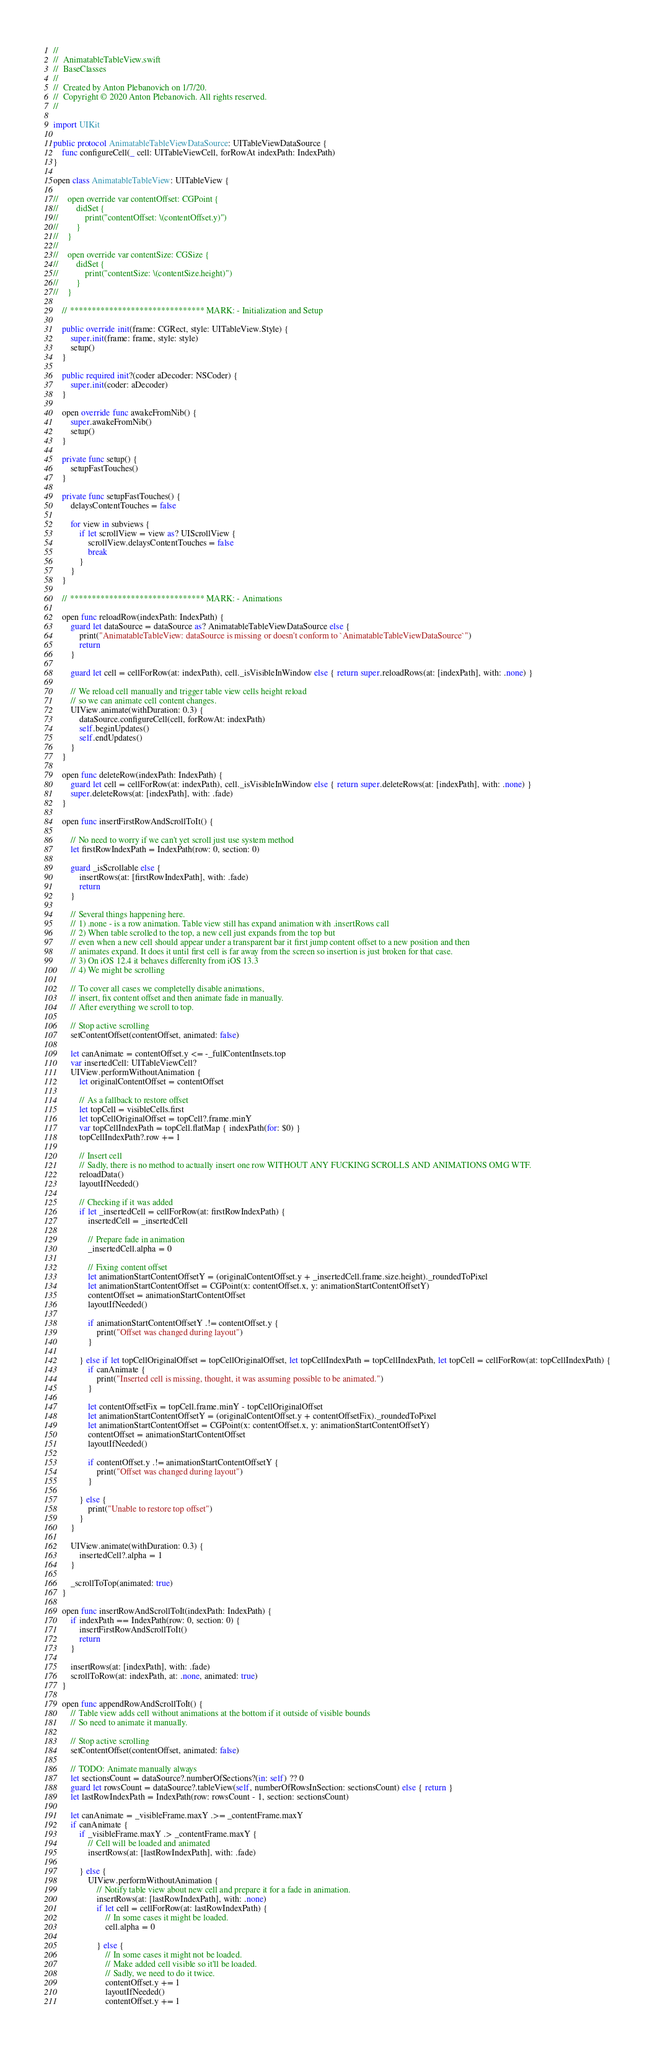<code> <loc_0><loc_0><loc_500><loc_500><_Swift_>//
//  AnimatableTableView.swift
//  BaseClasses
//
//  Created by Anton Plebanovich on 1/7/20.
//  Copyright © 2020 Anton Plebanovich. All rights reserved.
//

import UIKit

public protocol AnimatableTableViewDataSource: UITableViewDataSource {
    func configureCell(_ cell: UITableViewCell, forRowAt indexPath: IndexPath)
}

open class AnimatableTableView: UITableView {
    
//    open override var contentOffset: CGPoint {
//        didSet {
//            print("contentOffset: \(contentOffset.y)")
//        }
//    }
//    
//    open override var contentSize: CGSize {
//        didSet {
//            print("contentSize: \(contentSize.height)")
//        }
//    }
    
    // ******************************* MARK: - Initialization and Setup
    
    public override init(frame: CGRect, style: UITableView.Style) {
        super.init(frame: frame, style: style)
        setup()
    }
    
    public required init?(coder aDecoder: NSCoder) {
        super.init(coder: aDecoder)
    }
    
    open override func awakeFromNib() {
        super.awakeFromNib()
        setup()
    }
    
    private func setup() {
        setupFastTouches()
    }
    
    private func setupFastTouches() {
        delaysContentTouches = false
        
        for view in subviews {
            if let scrollView = view as? UIScrollView {
                scrollView.delaysContentTouches = false
                break
            }
        }
    }
    
    // ******************************* MARK: - Animations
    
    open func reloadRow(indexPath: IndexPath) {
        guard let dataSource = dataSource as? AnimatableTableViewDataSource else {
            print("AnimatableTableView: dataSource is missing or doesn't conform to `AnimatableTableViewDataSource`")
            return
        }
        
        guard let cell = cellForRow(at: indexPath), cell._isVisibleInWindow else { return super.reloadRows(at: [indexPath], with: .none) }
        
        // We reload cell manually and trigger table view cells height reload
        // so we can animate cell content changes.
        UIView.animate(withDuration: 0.3) {
            dataSource.configureCell(cell, forRowAt: indexPath)
            self.beginUpdates()
            self.endUpdates()
        }
    }
    
    open func deleteRow(indexPath: IndexPath) {
        guard let cell = cellForRow(at: indexPath), cell._isVisibleInWindow else { return super.deleteRows(at: [indexPath], with: .none) }
        super.deleteRows(at: [indexPath], with: .fade)
    }
    
    open func insertFirstRowAndScrollToIt() {
        
        // No need to worry if we can't yet scroll just use system method
        let firstRowIndexPath = IndexPath(row: 0, section: 0)
        
        guard _isScrollable else {
            insertRows(at: [firstRowIndexPath], with: .fade)
            return
        }
        
        // Several things happening here.
        // 1) .none - is a row animation. Table view still has expand animation with .insertRows call
        // 2) When table scrolled to the top, a new cell just expands from the top but
        // even when a new cell should appear under a transparent bar it first jump content offset to a new position and then
        // animates expand. It does it until first cell is far away from the screen so insertion is just broken for that case.
        // 3) On iOS 12.4 it behaves differenlty from iOS 13.3
        // 4) We might be scrolling
        
        // To cover all cases we completelly disable animations,
        // insert, fix content offset and then animate fade in manually.
        // After everything we scroll to top.
        
        // Stop active scrolling
        setContentOffset(contentOffset, animated: false)
        
        let canAnimate = contentOffset.y <= -_fullContentInsets.top
        var insertedCell: UITableViewCell?
        UIView.performWithoutAnimation {
            let originalContentOffset = contentOffset
            
            // As a fallback to restore offset
            let topCell = visibleCells.first
            let topCellOriginalOffset = topCell?.frame.minY
            var topCellIndexPath = topCell.flatMap { indexPath(for: $0) }
            topCellIndexPath?.row += 1
            
            // Insert cell
            // Sadly, there is no method to actually insert one row WITHOUT ANY FUCKING SCROLLS AND ANIMATIONS OMG WTF.
            reloadData()
            layoutIfNeeded()
            
            // Checking if it was added
            if let _insertedCell = cellForRow(at: firstRowIndexPath) {
                insertedCell = _insertedCell
                
                // Prepare fade in animation
                _insertedCell.alpha = 0
                
                // Fixing content offset
                let animationStartContentOffsetY = (originalContentOffset.y + _insertedCell.frame.size.height)._roundedToPixel
                let animationStartContentOffset = CGPoint(x: contentOffset.x, y: animationStartContentOffsetY)
                contentOffset = animationStartContentOffset
                layoutIfNeeded()
                    
                if animationStartContentOffsetY .!= contentOffset.y {
                    print("Offset was changed during layout")
                }
                
            } else if let topCellOriginalOffset = topCellOriginalOffset, let topCellIndexPath = topCellIndexPath, let topCell = cellForRow(at: topCellIndexPath) {
                if canAnimate {
                    print("Inserted cell is missing, thought, it was assuming possible to be animated.")
                }
                
                let contentOffsetFix = topCell.frame.minY - topCellOriginalOffset
                let animationStartContentOffsetY = (originalContentOffset.y + contentOffsetFix)._roundedToPixel
                let animationStartContentOffset = CGPoint(x: contentOffset.x, y: animationStartContentOffsetY)
                contentOffset = animationStartContentOffset
                layoutIfNeeded()
                
                if contentOffset.y .!= animationStartContentOffsetY {
                    print("Offset was changed during layout")
                }
                
            } else {
                print("Unable to restore top offset")
            }
        }
        
        UIView.animate(withDuration: 0.3) {
            insertedCell?.alpha = 1
        }
        
        _scrollToTop(animated: true)
    }
    
    open func insertRowAndScrollToIt(indexPath: IndexPath) {
        if indexPath == IndexPath(row: 0, section: 0) {
            insertFirstRowAndScrollToIt()
            return
        }
        
        insertRows(at: [indexPath], with: .fade)
        scrollToRow(at: indexPath, at: .none, animated: true)
    }
    
    open func appendRowAndScrollToIt() {
        // Table view adds cell without animations at the bottom if it outside of visible bounds
        // So need to animate it manually.
        
        // Stop active scrolling
        setContentOffset(contentOffset, animated: false)
        
        // TODO: Animate manually always
        let sectionsCount = dataSource?.numberOfSections?(in: self) ?? 0
        guard let rowsCount = dataSource?.tableView(self, numberOfRowsInSection: sectionsCount) else { return }
        let lastRowIndexPath = IndexPath(row: rowsCount - 1, section: sectionsCount)
        
        let canAnimate = _visibleFrame.maxY .>= _contentFrame.maxY
        if canAnimate {
            if _visibleFrame.maxY .> _contentFrame.maxY {
                // Cell will be loaded and animated
                insertRows(at: [lastRowIndexPath], with: .fade)
                
            } else {
                UIView.performWithoutAnimation {
                    // Notify table view about new cell and prepare it for a fade in animation.
                    insertRows(at: [lastRowIndexPath], with: .none)
                    if let cell = cellForRow(at: lastRowIndexPath) {
                        // In some cases it might be loaded.
                        cell.alpha = 0
                        
                    } else {
                        // In some cases it might not be loaded.
                        // Make added cell visible so it'll be loaded.
                        // Sadly, we need to do it twice.
                        contentOffset.y += 1
                        layoutIfNeeded()
                        contentOffset.y += 1</code> 